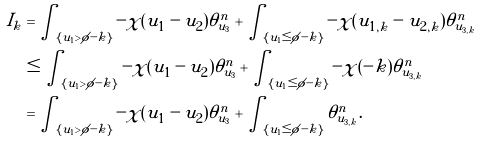<formula> <loc_0><loc_0><loc_500><loc_500>I _ { k } & = \int _ { \{ u _ { 1 } > \phi - k \} } - \chi ( u _ { 1 } - u _ { 2 } ) \theta _ { u _ { 3 } } ^ { n } + \int _ { \{ u _ { 1 } \leq \phi - k \} } - \chi ( u _ { 1 , k } - u _ { 2 , k } ) \theta _ { u _ { 3 , k } } ^ { n } \\ & \leq \int _ { \{ u _ { 1 } > \phi - k \} } - \chi ( u _ { 1 } - u _ { 2 } ) \theta _ { u _ { 3 } } ^ { n } + \int _ { \{ u _ { 1 } \leq \phi - k \} } - \chi ( - k ) \theta _ { u _ { 3 , k } } ^ { n } \\ & = \int _ { \{ u _ { 1 } > \phi - k \} } - \chi ( u _ { 1 } - u _ { 2 } ) \theta _ { u _ { 3 } } ^ { n } + \int _ { \{ u _ { 1 } \leq \phi - k \} } \theta _ { u _ { 3 , k } } ^ { n } .</formula> 